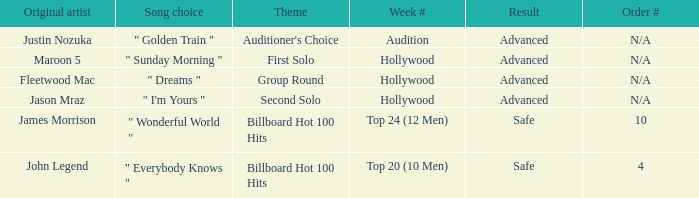What are all the results of songs is " golden train " Advanced. 